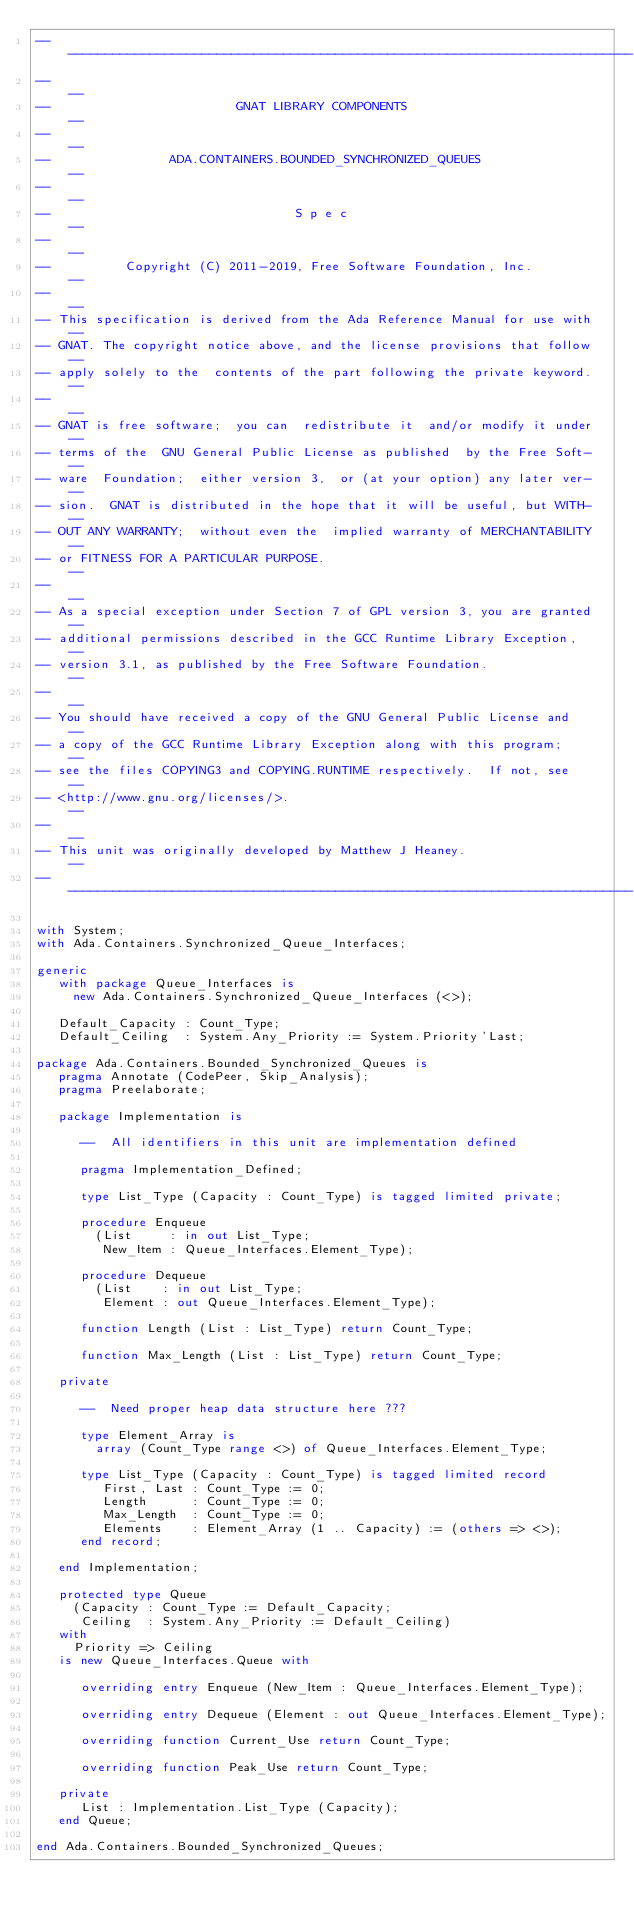Convert code to text. <code><loc_0><loc_0><loc_500><loc_500><_Ada_>------------------------------------------------------------------------------
--                                                                          --
--                         GNAT LIBRARY COMPONENTS                          --
--                                                                          --
--                ADA.CONTAINERS.BOUNDED_SYNCHRONIZED_QUEUES                --
--                                                                          --
--                                 S p e c                                  --
--                                                                          --
--          Copyright (C) 2011-2019, Free Software Foundation, Inc.         --
--                                                                          --
-- This specification is derived from the Ada Reference Manual for use with --
-- GNAT. The copyright notice above, and the license provisions that follow --
-- apply solely to the  contents of the part following the private keyword. --
--                                                                          --
-- GNAT is free software;  you can  redistribute it  and/or modify it under --
-- terms of the  GNU General Public License as published  by the Free Soft- --
-- ware  Foundation;  either version 3,  or (at your option) any later ver- --
-- sion.  GNAT is distributed in the hope that it will be useful, but WITH- --
-- OUT ANY WARRANTY;  without even the  implied warranty of MERCHANTABILITY --
-- or FITNESS FOR A PARTICULAR PURPOSE.                                     --
--                                                                          --
-- As a special exception under Section 7 of GPL version 3, you are granted --
-- additional permissions described in the GCC Runtime Library Exception,   --
-- version 3.1, as published by the Free Software Foundation.               --
--                                                                          --
-- You should have received a copy of the GNU General Public License and    --
-- a copy of the GCC Runtime Library Exception along with this program;     --
-- see the files COPYING3 and COPYING.RUNTIME respectively.  If not, see    --
-- <http://www.gnu.org/licenses/>.                                          --
--                                                                          --
-- This unit was originally developed by Matthew J Heaney.                  --
------------------------------------------------------------------------------

with System;
with Ada.Containers.Synchronized_Queue_Interfaces;

generic
   with package Queue_Interfaces is
     new Ada.Containers.Synchronized_Queue_Interfaces (<>);

   Default_Capacity : Count_Type;
   Default_Ceiling  : System.Any_Priority := System.Priority'Last;

package Ada.Containers.Bounded_Synchronized_Queues is
   pragma Annotate (CodePeer, Skip_Analysis);
   pragma Preelaborate;

   package Implementation is

      --  All identifiers in this unit are implementation defined

      pragma Implementation_Defined;

      type List_Type (Capacity : Count_Type) is tagged limited private;

      procedure Enqueue
        (List     : in out List_Type;
         New_Item : Queue_Interfaces.Element_Type);

      procedure Dequeue
        (List    : in out List_Type;
         Element : out Queue_Interfaces.Element_Type);

      function Length (List : List_Type) return Count_Type;

      function Max_Length (List : List_Type) return Count_Type;

   private

      --  Need proper heap data structure here ???

      type Element_Array is
        array (Count_Type range <>) of Queue_Interfaces.Element_Type;

      type List_Type (Capacity : Count_Type) is tagged limited record
         First, Last : Count_Type := 0;
         Length      : Count_Type := 0;
         Max_Length  : Count_Type := 0;
         Elements    : Element_Array (1 .. Capacity) := (others => <>);
      end record;

   end Implementation;

   protected type Queue
     (Capacity : Count_Type := Default_Capacity;
      Ceiling  : System.Any_Priority := Default_Ceiling)
   with
     Priority => Ceiling
   is new Queue_Interfaces.Queue with

      overriding entry Enqueue (New_Item : Queue_Interfaces.Element_Type);

      overriding entry Dequeue (Element : out Queue_Interfaces.Element_Type);

      overriding function Current_Use return Count_Type;

      overriding function Peak_Use return Count_Type;

   private
      List : Implementation.List_Type (Capacity);
   end Queue;

end Ada.Containers.Bounded_Synchronized_Queues;
</code> 